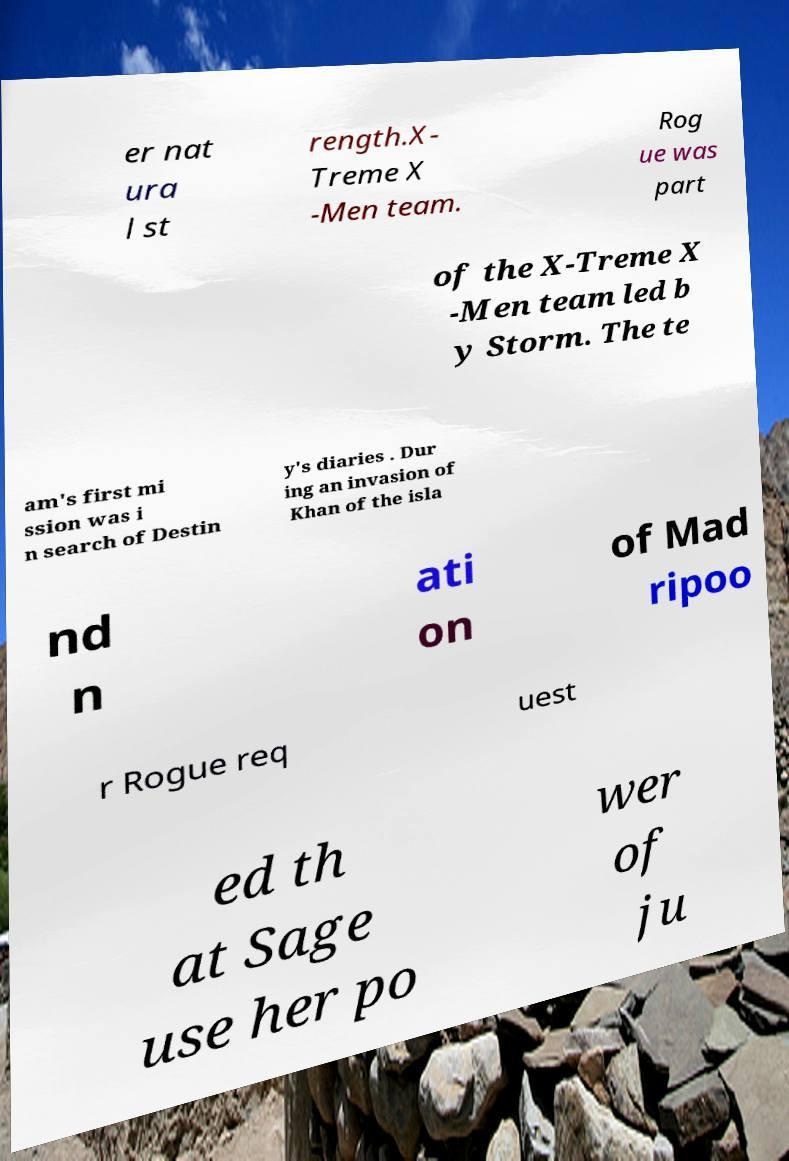For documentation purposes, I need the text within this image transcribed. Could you provide that? er nat ura l st rength.X- Treme X -Men team. Rog ue was part of the X-Treme X -Men team led b y Storm. The te am's first mi ssion was i n search of Destin y's diaries . Dur ing an invasion of Khan of the isla nd n ati on of Mad ripoo r Rogue req uest ed th at Sage use her po wer of ju 